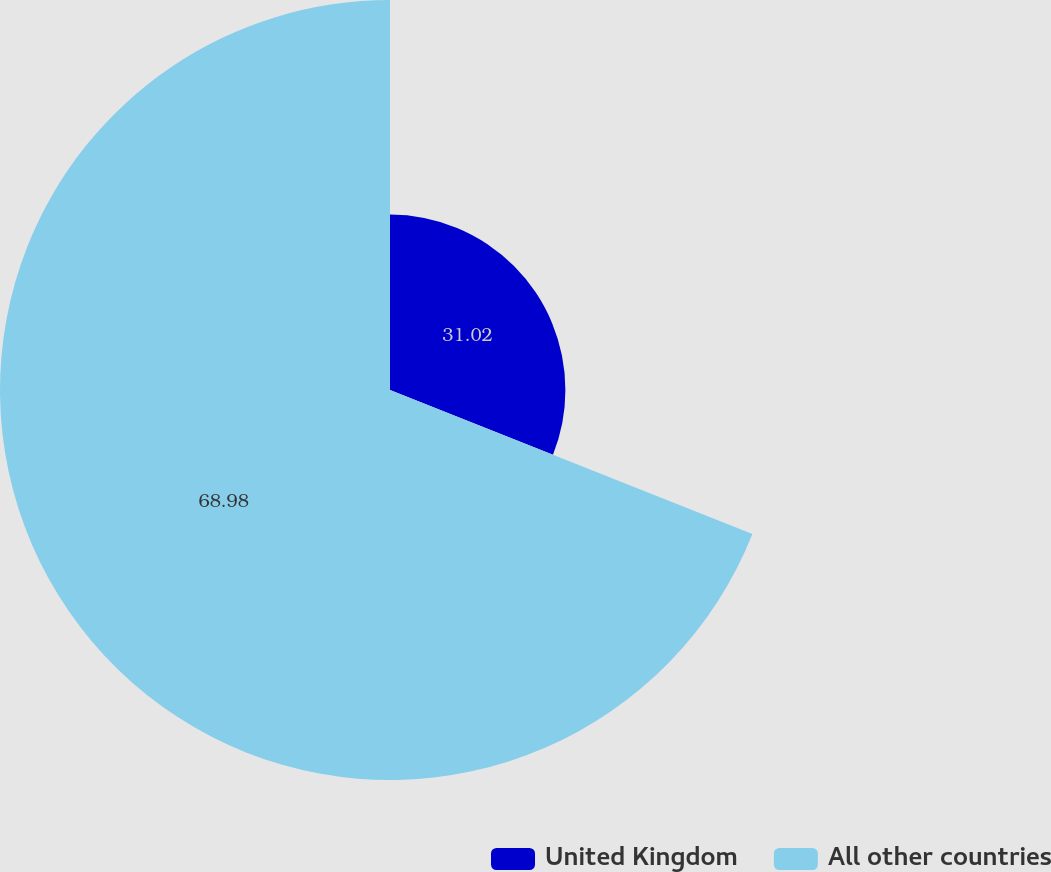Convert chart. <chart><loc_0><loc_0><loc_500><loc_500><pie_chart><fcel>United Kingdom<fcel>All other countries<nl><fcel>31.02%<fcel>68.98%<nl></chart> 